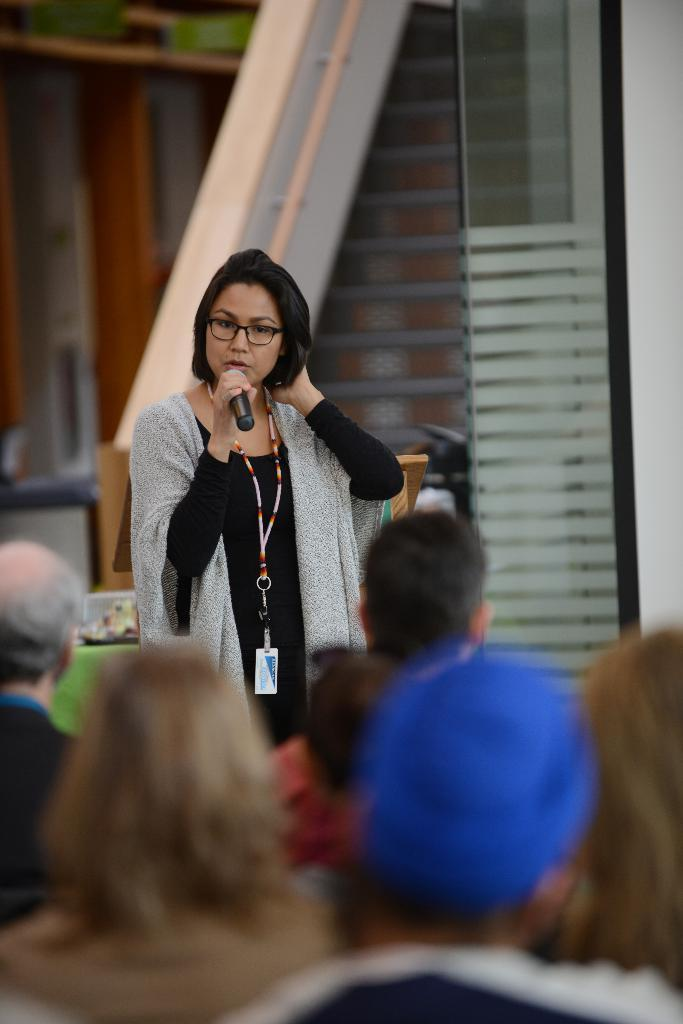What is the main subject of the image? People are present in the image. Can you describe the woman in the image? There is a woman standing in the image. What is the woman wearing in the image? The woman is wearing an ID card. What object is the woman holding in the image? The woman is holding a microphone. What type of glove is the woman wearing in the image? The woman is not wearing a glove in the image. Who is the owner of the microphone in the image? The facts provided do not indicate the ownership of the microphone. 